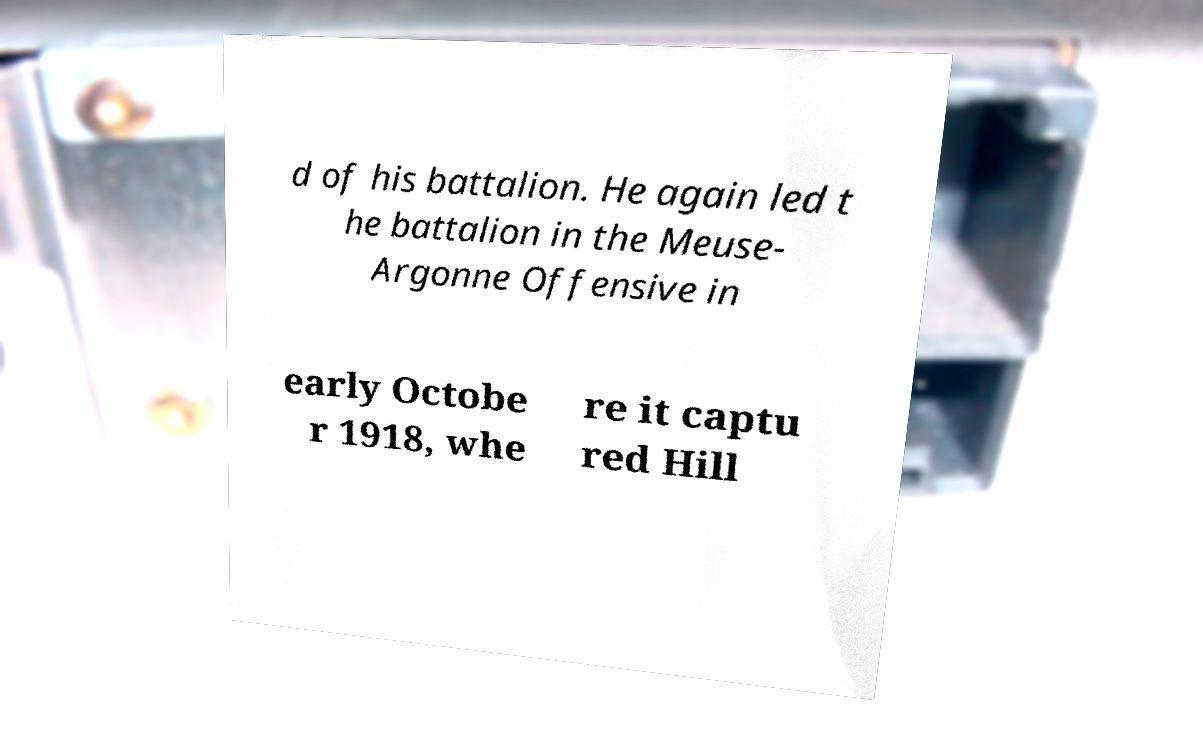I need the written content from this picture converted into text. Can you do that? d of his battalion. He again led t he battalion in the Meuse- Argonne Offensive in early Octobe r 1918, whe re it captu red Hill 